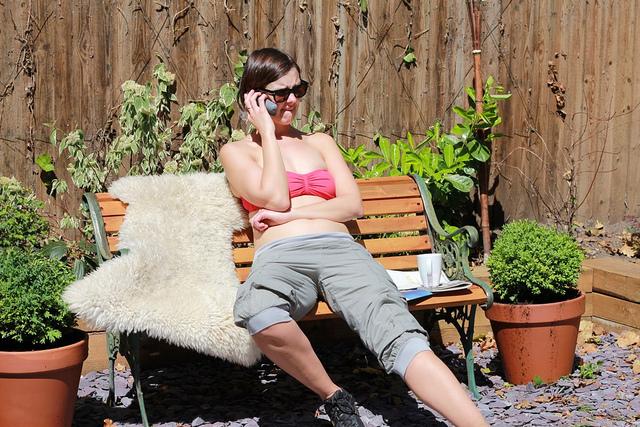Is it sunny?
Write a very short answer. Yes. Is the woman likely to wrap up in the fleece?
Short answer required. No. How many people are shown?
Write a very short answer. 1. Is she going to get sunburned?
Answer briefly. Yes. 